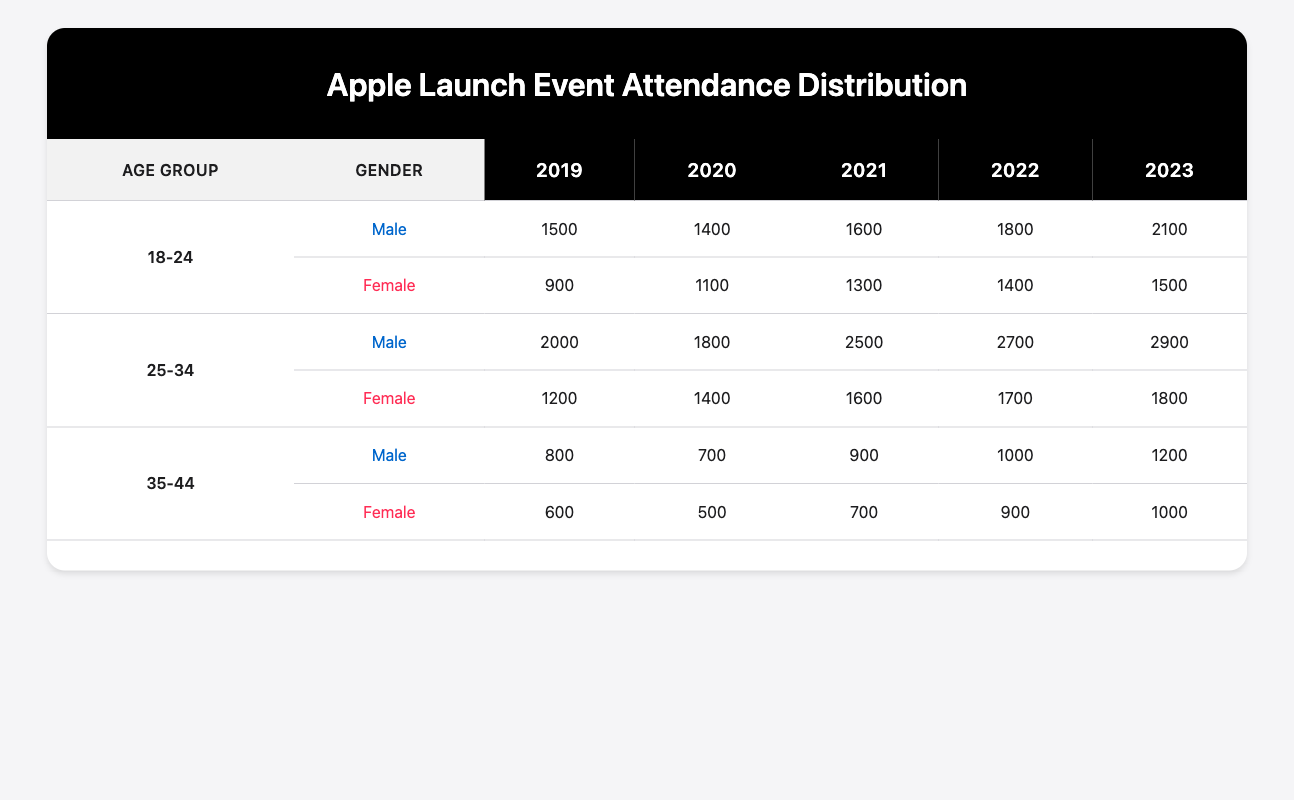What was the total attendance for male attendees in the age group 25-34 over the last five years? To find the total attendance for male attendees aged 25-34, we add the attendance from each year: 2000 (2019) + 1800 (2020) + 2500 (2021) + 2700 (2022) + 2900 (2023) = 14500.
Answer: 14500 In which year did female attendees aged 18-24 have the highest attendance? Looking at the attendance numbers for female attendees aged 18-24 for each year, we see 900 (2019), 1100 (2020), 1300 (2021), 1400 (2022), and 1500 (2023). The highest attendance is 1500 in 2023.
Answer: 2023 Is it true that male attendees in the age group 35-44 had more attendance in 2022 than in 2021? In 2021, male attendees aged 35-44 had an attendance of 900, while in 2022 they had 1000. Since 1000 > 900, the statement is true.
Answer: Yes What is the average attendance for female attendees in the age group 25-34 over the five years? The attendance for female attendees aged 25-34 is: 1200 (2019), 1400 (2020), 1600 (2021), 1700 (2022), 1800 (2023). The average is calculated by summing these values (1200 + 1400 + 1600 + 1700 + 1800 = 10800) and then dividing by 5, which gives us 10800 / 5 = 2160.
Answer: 2160 Which age group had the lowest total attendance among male attendees in 2019? For male attendees in 2019, we have: 1500 for 18-24, 2000 for 25-34, and 800 for 35-44. The lowest total attendance is 800 for the age group 35-44.
Answer: 35-44 